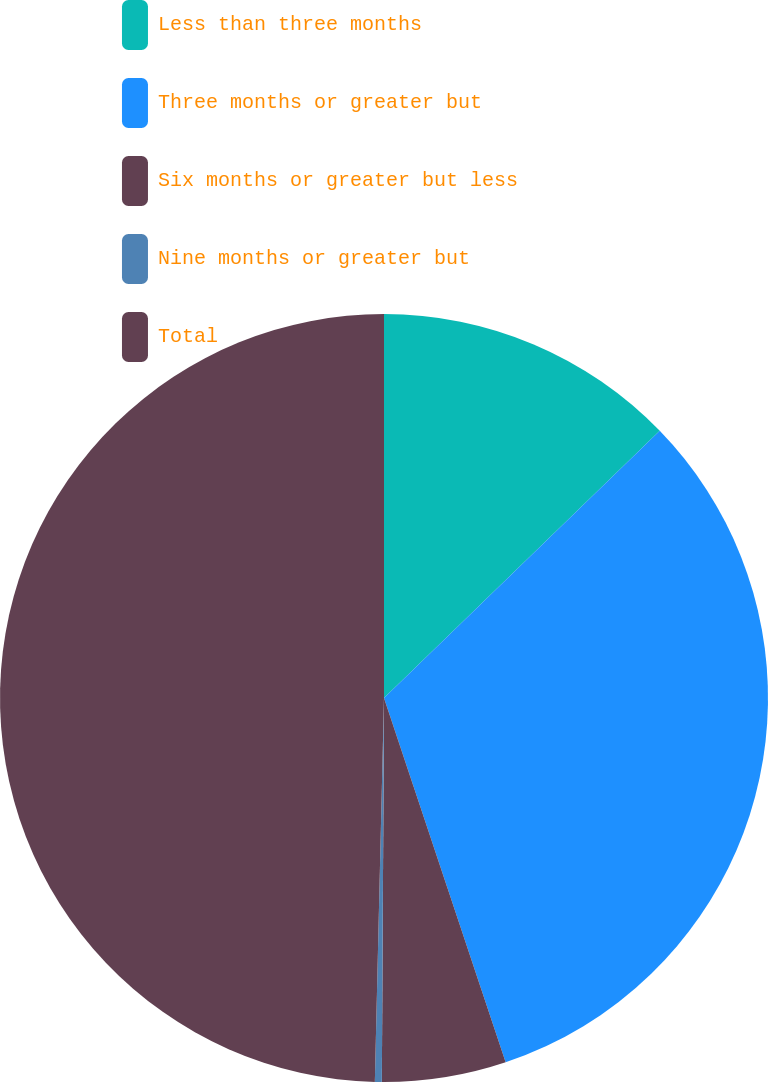Convert chart to OTSL. <chart><loc_0><loc_0><loc_500><loc_500><pie_chart><fcel>Less than three months<fcel>Three months or greater but<fcel>Six months or greater but less<fcel>Nine months or greater but<fcel>Total<nl><fcel>12.75%<fcel>32.12%<fcel>5.22%<fcel>0.29%<fcel>49.62%<nl></chart> 